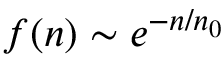<formula> <loc_0><loc_0><loc_500><loc_500>f ( n ) \sim e ^ { - n / n _ { 0 } }</formula> 